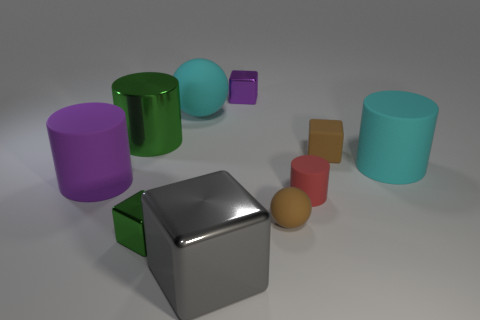Subtract all metallic cylinders. How many cylinders are left? 3 Subtract 1 cyan cylinders. How many objects are left? 9 Subtract all blocks. How many objects are left? 6 Subtract 2 spheres. How many spheres are left? 0 Subtract all cyan blocks. Subtract all green spheres. How many blocks are left? 4 Subtract all purple spheres. How many green cylinders are left? 1 Subtract all large purple objects. Subtract all small green metal things. How many objects are left? 8 Add 3 big cyan matte spheres. How many big cyan matte spheres are left? 4 Add 3 green things. How many green things exist? 5 Subtract all brown balls. How many balls are left? 1 